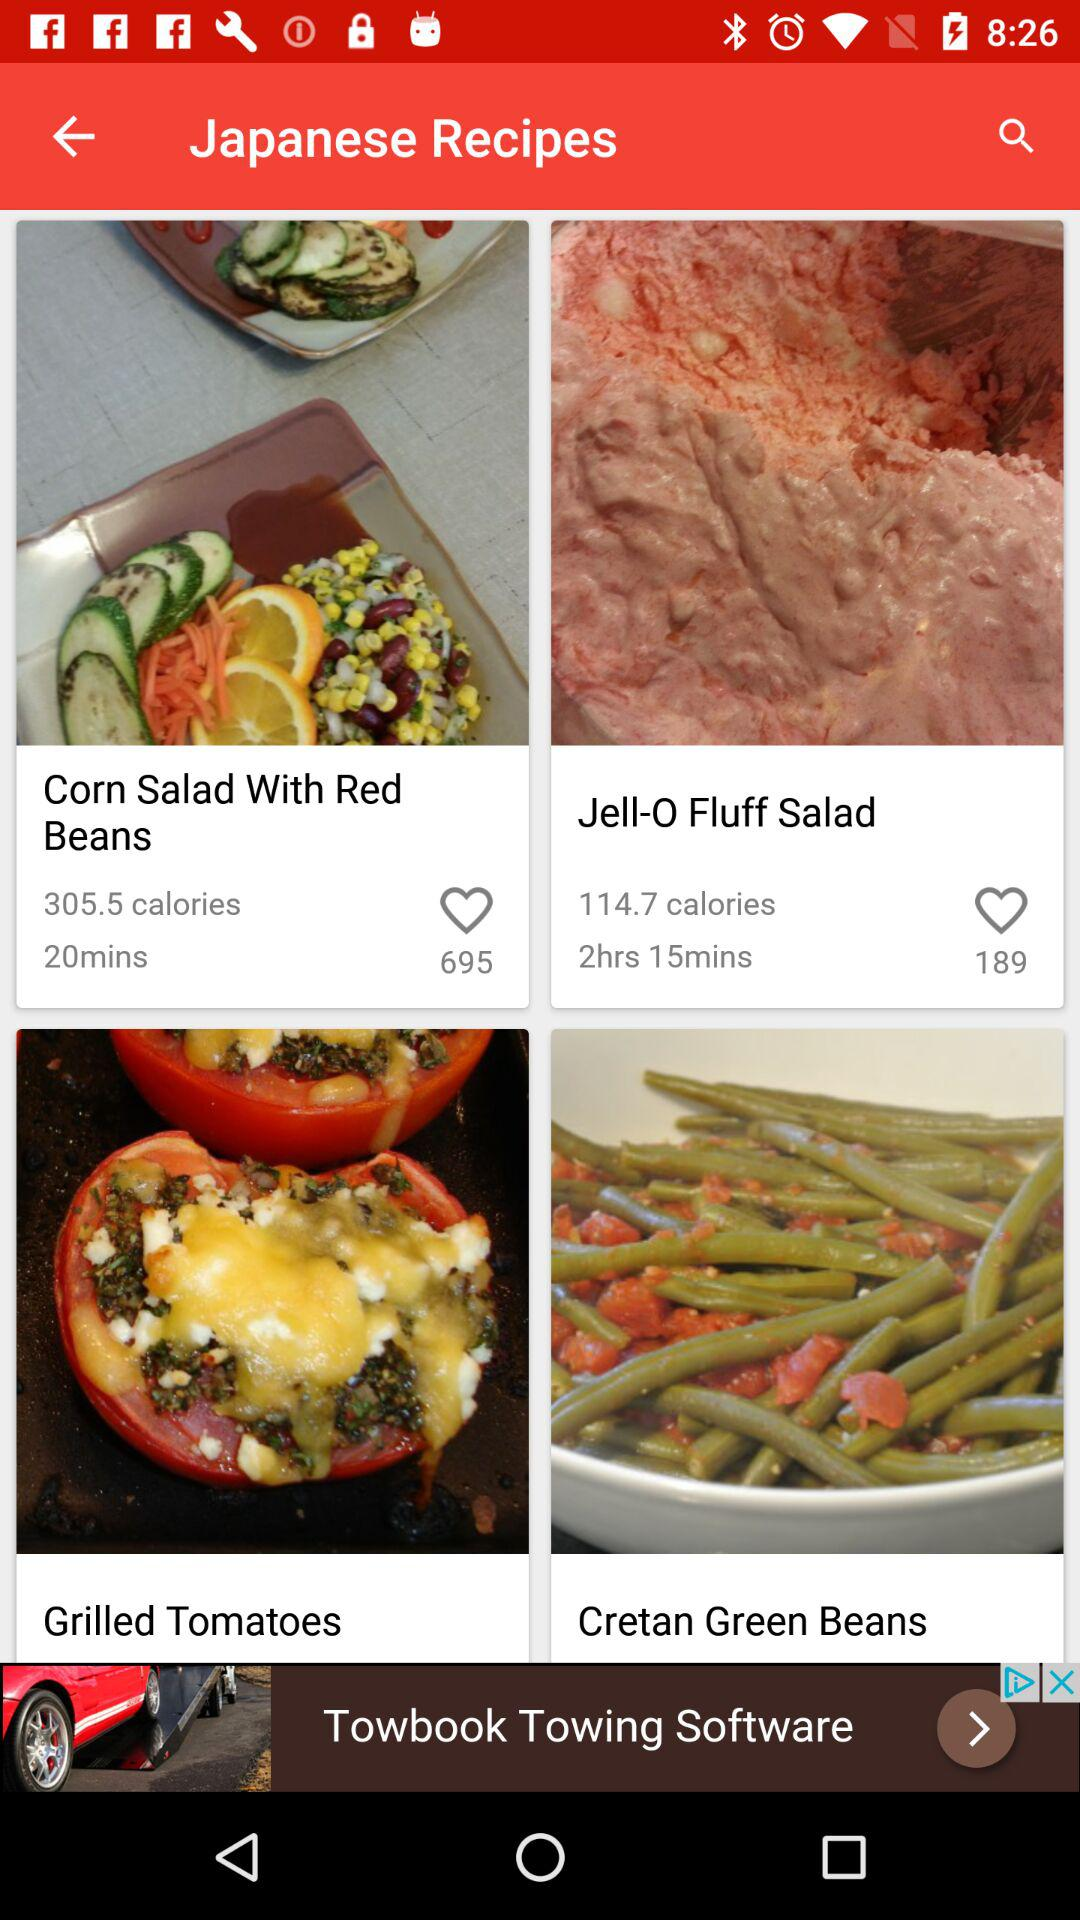How many likes for the recipe "Corn Salad With Red Beans"? The recipe has received 695 likes. 